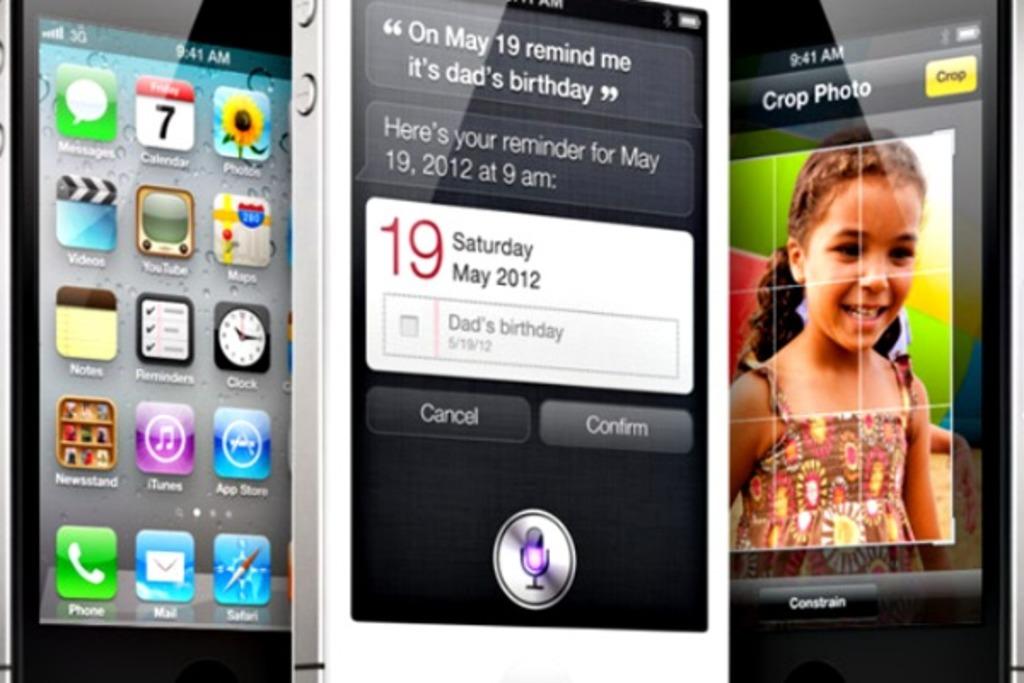When is it dad's birthday?
Give a very brief answer. May 19. What time does the phone show?
Provide a succinct answer. 9:41. 